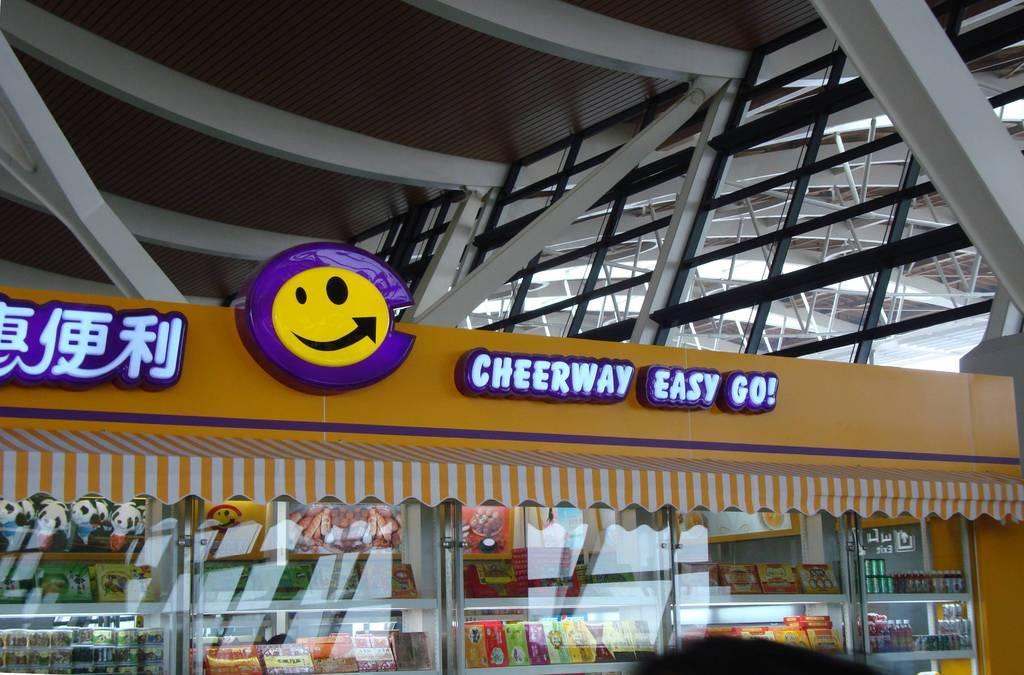Describe this image in one or two sentences. In this picture there is a stall at the bottom with a picture and some text. On the top there are rods and a roof. 